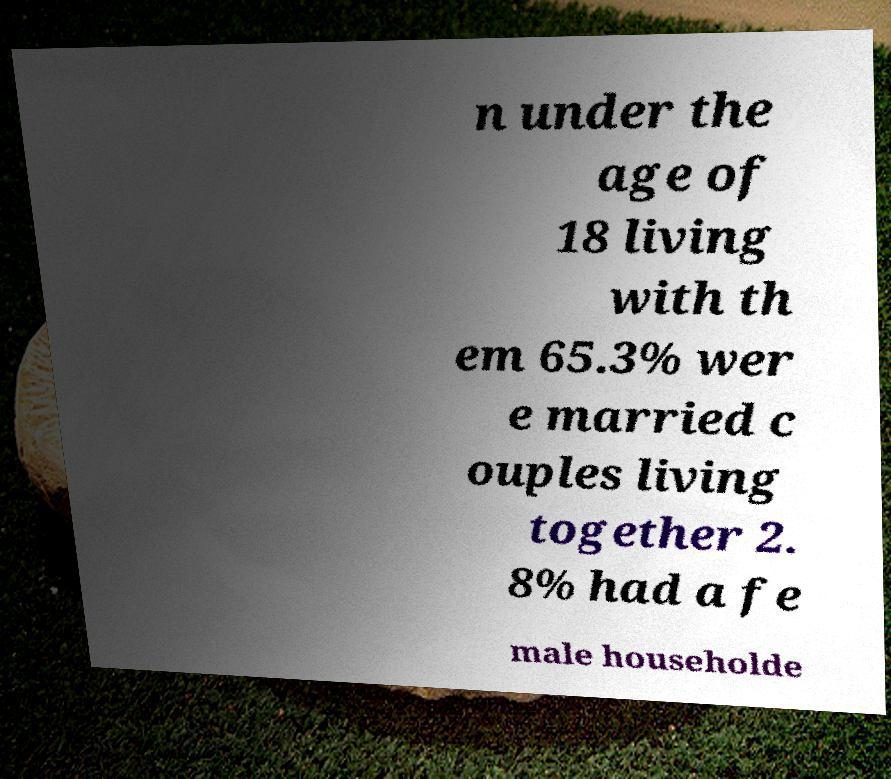Please identify and transcribe the text found in this image. n under the age of 18 living with th em 65.3% wer e married c ouples living together 2. 8% had a fe male householde 